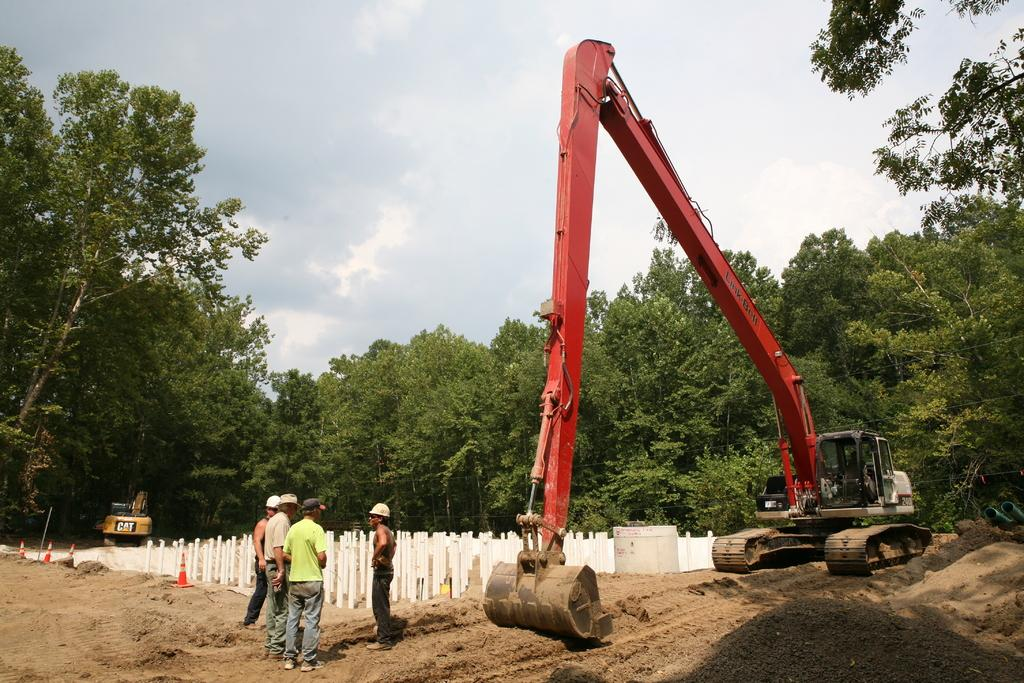What type of large birds are on the ground in the image? There are cranes on the ground in the image. What safety equipment is present in the image? There are traffic cones in the image. Can you describe the people in the image? There are people in the image. What structures are present in the image? There are poles in the image. What type of vegetation is visible in the image? There are trees in the image. What can be seen in the background of the image? The sky with clouds is visible in the background of the image. How many toes can be seen on the cranes in the image? Cranes do not have toes; they have talons. However, the image does not show any visible talons. What type of wire is being used by the people in the image? There is no wire present in the image. 